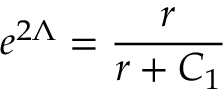<formula> <loc_0><loc_0><loc_500><loc_500>e ^ { 2 \Lambda } = \frac { r } { r + C _ { 1 } }</formula> 